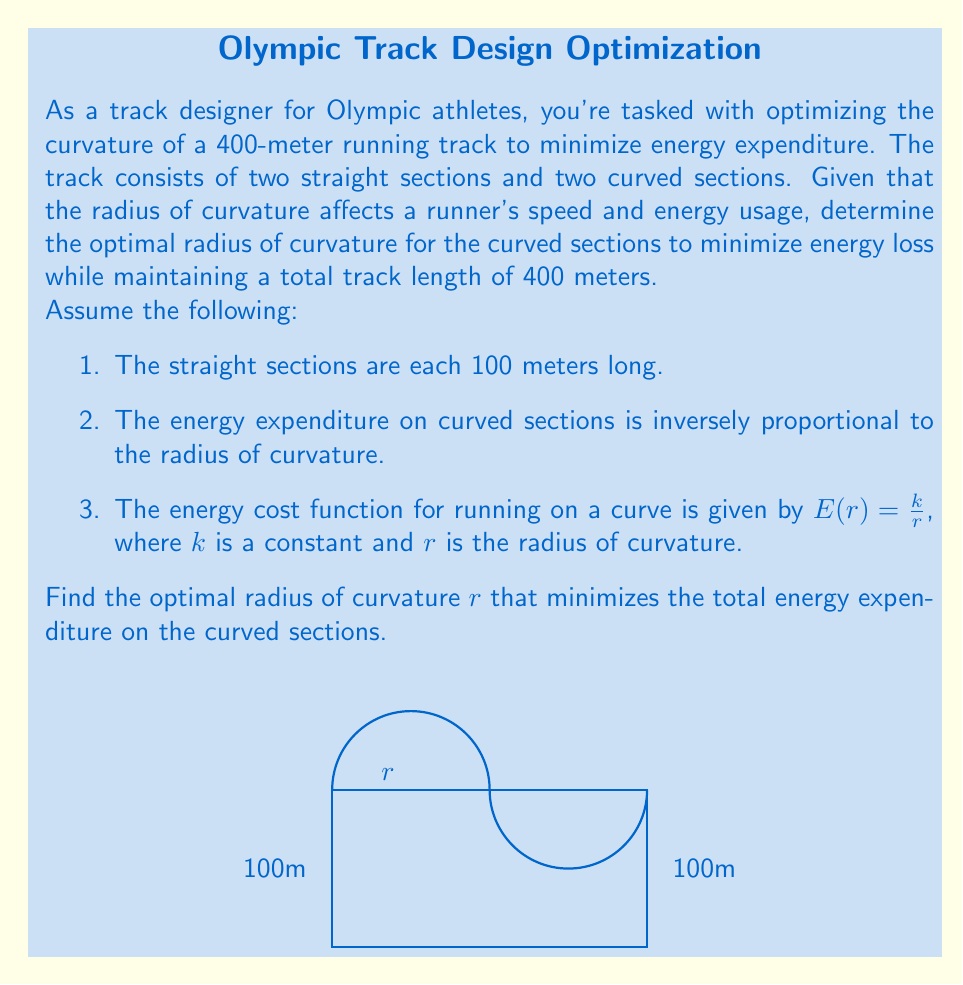Provide a solution to this math problem. Let's approach this step-by-step:

1) First, we need to express the length of the curved sections in terms of $r$. The total length of the two curved sections is:

   $$L_{curved} = 2\pi r$$

2) We know the total track length is 400m, and the straight sections are 200m in total. So:

   $$400 = 200 + 2\pi r$$

3) Solving for $r$:

   $$r = \frac{200}{\pi} \approx 63.66\text{ meters}$$

4) Now, let's consider the energy expenditure. The total energy spent on the curved sections is:

   $$E_{total} = 2\pi r \cdot \frac{k}{r} = 2\pi k$$

5) This shows that the total energy expenditure is constant regardless of $r$. However, we need to minimize this while maintaining the 400m track length.

6) The constraint of the 400m track length means we can't freely change $r$. The optimal solution is to use the largest possible $r$ that still allows for the 400m total length.

7) This optimal $r$ is the one we calculated in step 3:

   $$r_{optimal} = \frac{200}{\pi} \approx 63.66\text{ meters}$$

This radius maximizes the straightness of the curved sections while maintaining the required total length, thus minimizing the energy expenditure due to curvature.
Answer: $r_{optimal} = \frac{200}{\pi} \approx 63.66\text{ meters}$ 